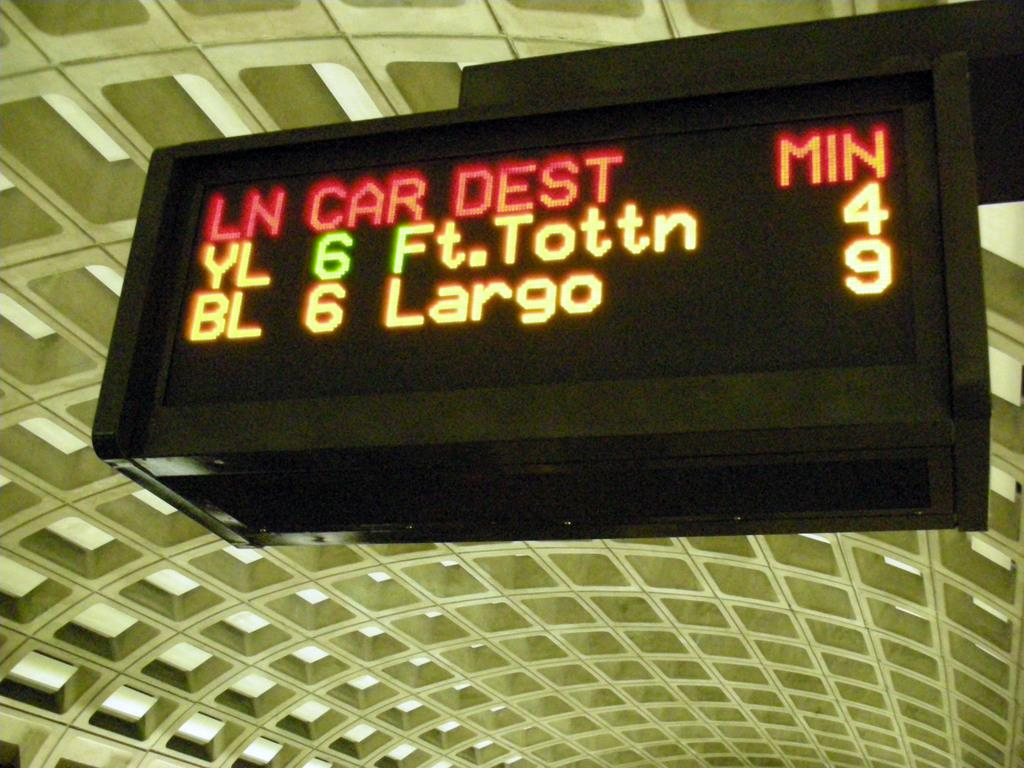<image>
Write a terse but informative summary of the picture. An electronic metro sign that says "YL 6 Ft. Tottn 4" 